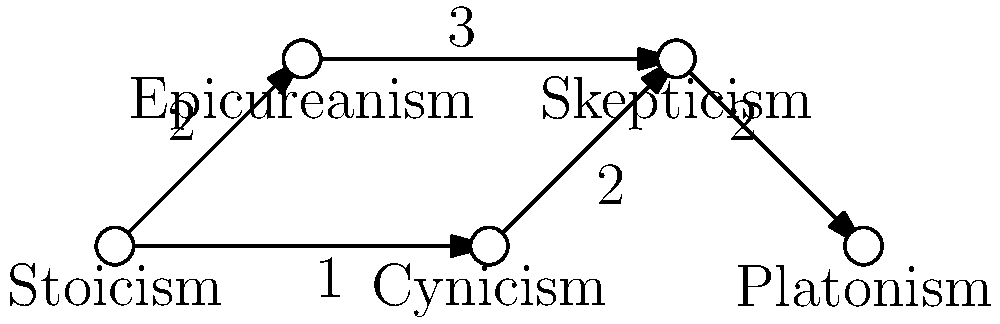In the philosophical schools of thought graph, what is the shortest path from Stoicism to Platonism, and what is its total weight? To find the shortest path from Stoicism to Platonism, we need to consider all possible paths and their weights:

1. Stoicism → Epicureanism → Skepticism → Platonism
   Weight: 2 + 3 + 2 = 7

2. Stoicism → Cynicism → Skepticism → Platonism
   Weight: 1 + 2 + 2 = 5

Let's break down the second path, which is the shortest:

1. Stoicism to Cynicism: weight 1
2. Cynicism to Skepticism: weight 2
3. Skepticism to Platonism: weight 2

The total weight of this path is 1 + 2 + 2 = 5, which is less than the first path's weight of 7.

Therefore, the shortest path from Stoicism to Platonism is:
Stoicism → Cynicism → Skepticism → Platonism

The total weight of this path is 5.
Answer: Stoicism → Cynicism → Skepticism → Platonism; weight 5 